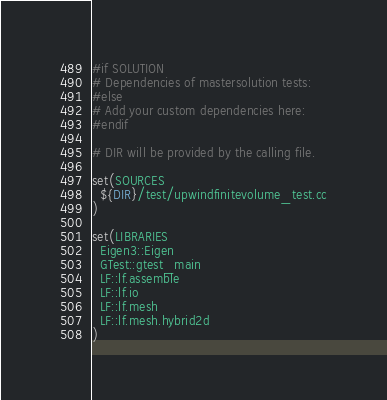<code> <loc_0><loc_0><loc_500><loc_500><_CMake_>#if SOLUTION
# Dependencies of mastersolution tests:
#else
# Add your custom dependencies here:
#endif

# DIR will be provided by the calling file.

set(SOURCES
  ${DIR}/test/upwindfinitevolume_test.cc
)

set(LIBRARIES
  Eigen3::Eigen
  GTest::gtest_main
  LF::lf.assemble
  LF::lf.io
  LF::lf.mesh
  LF::lf.mesh.hybrid2d
)
</code> 